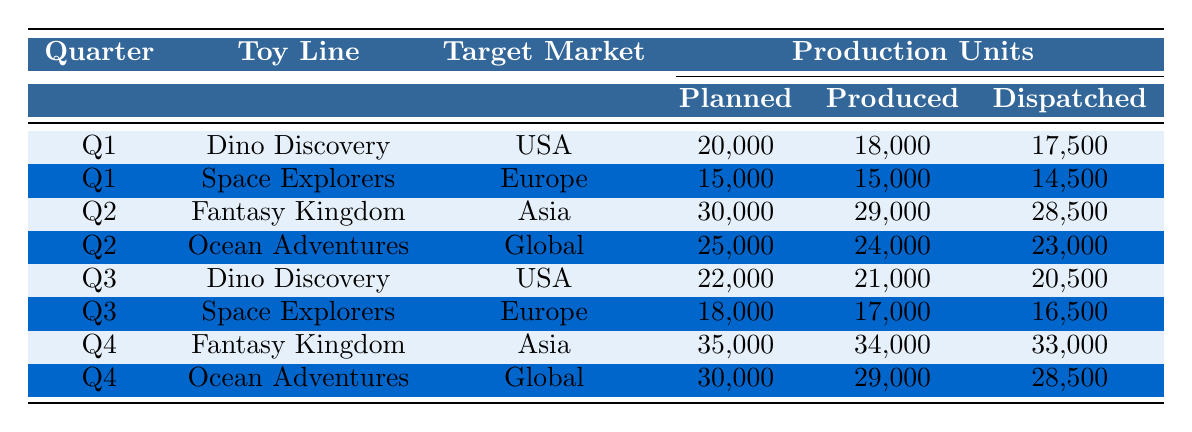What is the total number of units planned for the "Dino Discovery" toy line in Q1 and Q3? In Q1, "Dino Discovery" had 20,000 units planned, and in Q3, it had 22,000 units planned. The total is 20,000 + 22,000 = 42,000.
Answer: 42,000 How many units were produced for "Fantasy Kingdom" in Q2? The table shows that in Q2, the "Fantasy Kingdom" toy line had 29,000 units produced.
Answer: 29,000 What percentage of units planned for "Ocean Adventures" in Q4 were dispatched? In Q4, "Ocean Adventures" had 30,000 units planned and 28,500 units dispatched. To find the percentage: (28,500 / 30,000) * 100 = 95%.
Answer: 95% Did "Space Explorers" reach its production goal in Q1? In Q1, "Space Explorers" had 15,000 units planned and produced exactly 15,000 units. Therefore, it did meet its production goal.
Answer: Yes What is the average number of units produced across all toy lines in Q2? In Q2, "Fantasy Kingdom" produced 29,000 units and "Ocean Adventures" produced 24,000 units. The average is calculated as (29,000 + 24,000) / 2 = 26,500.
Answer: 26,500 Was there any quarter where the units dispatched for "Dino Discovery" were less than 90% of the units produced? For "Dino Discovery," in Q1, it produced 18,000 and dispatched 17,500 (17,500/18,000 = 97.22%), and in Q3, it produced 21,000 and dispatched 20,500 (20,500/21,000 = 97.62%). Neither quarter had dispatched units below 90% of produced units.
Answer: No Which toy line had the highest number of units planned in Q4? In Q4, "Fantasy Kingdom" had 35,000 units planned, which is higher than any other toy line in that quarter.
Answer: Fantasy Kingdom How many fewer units were dispatched than produced for "Ocean Adventures" in Q2? In Q2, "Ocean Adventures" had 24,000 units produced and 23,000 units dispatched. The difference is 24,000 - 23,000 = 1,000 units.
Answer: 1,000 What is the total number of units planned for all toy lines in Q1? In Q1, "Dino Discovery" had 20,000 planned, and "Space Explorers" had 15,000 planned. The total is 20,000 + 15,000 = 35,000.
Answer: 35,000 Which toy line has the maximum units dispatched across all quarters? The maximum number of units dispatched was 33,000 for "Fantasy Kingdom" in Q4.
Answer: Fantasy Kingdom 